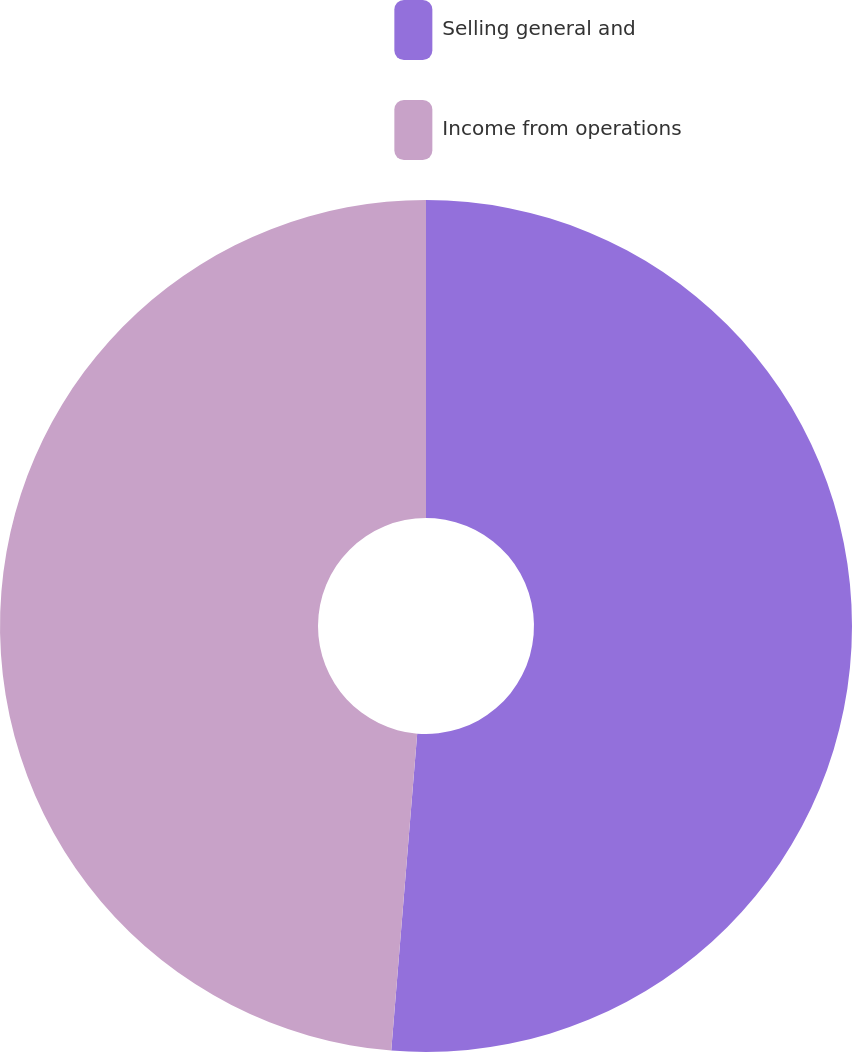Convert chart to OTSL. <chart><loc_0><loc_0><loc_500><loc_500><pie_chart><fcel>Selling general and<fcel>Income from operations<nl><fcel>51.3%<fcel>48.7%<nl></chart> 